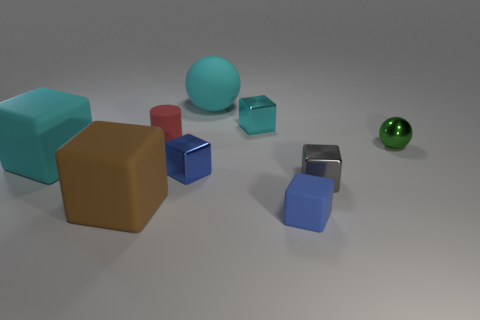The other large thing that is the same shape as the large brown object is what color?
Provide a short and direct response. Cyan. Is the number of tiny objects that are left of the small metal sphere greater than the number of large cubes that are on the right side of the gray shiny cube?
Offer a terse response. Yes. How many other things are the same shape as the cyan metal object?
Your response must be concise. 5. There is a blue thing that is in front of the gray cube; are there any brown blocks that are to the right of it?
Your answer should be compact. No. How many tiny rubber objects are there?
Make the answer very short. 2. Does the large sphere have the same color as the large rubber block behind the gray block?
Keep it short and to the point. Yes. Is the number of tiny matte cubes greater than the number of blue things?
Give a very brief answer. No. Is there any other thing of the same color as the big matte ball?
Give a very brief answer. Yes. How many other objects are the same size as the red object?
Make the answer very short. 5. The small cube left of the big object behind the tiny cube that is behind the tiny red rubber cylinder is made of what material?
Offer a terse response. Metal. 